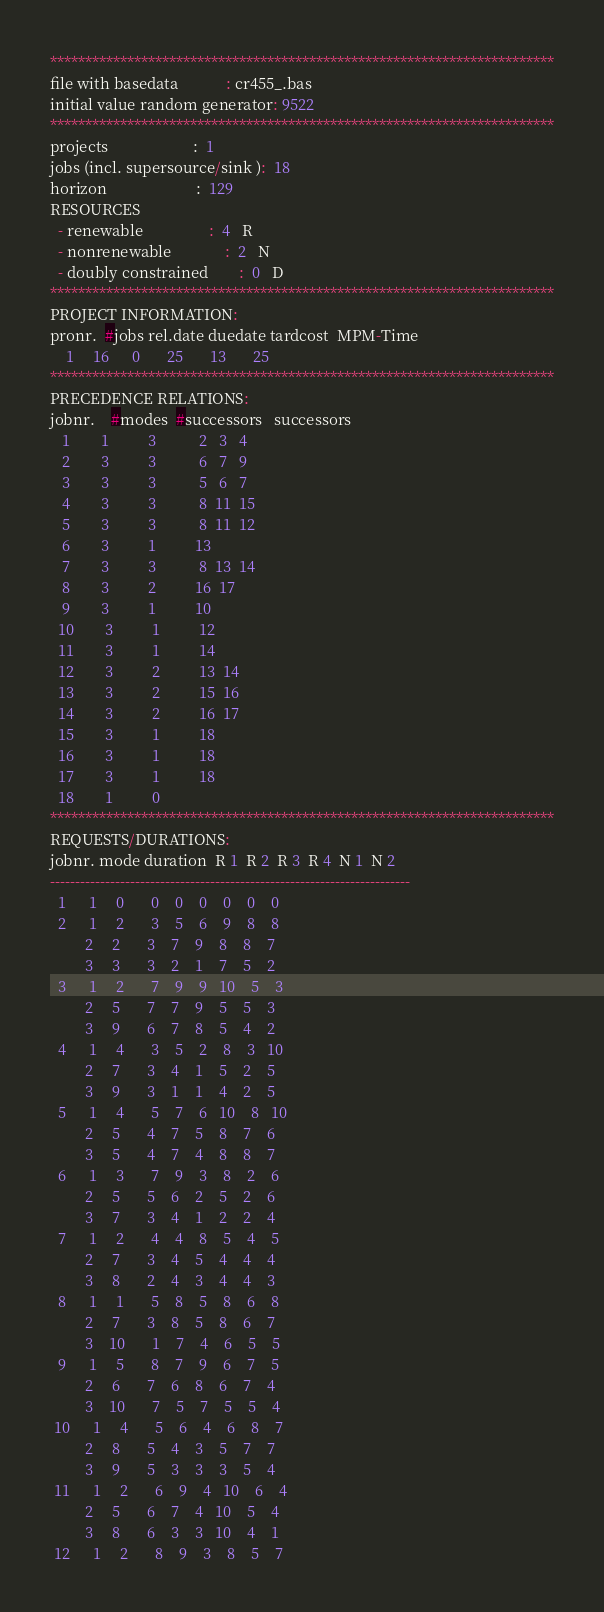<code> <loc_0><loc_0><loc_500><loc_500><_ObjectiveC_>************************************************************************
file with basedata            : cr455_.bas
initial value random generator: 9522
************************************************************************
projects                      :  1
jobs (incl. supersource/sink ):  18
horizon                       :  129
RESOURCES
  - renewable                 :  4   R
  - nonrenewable              :  2   N
  - doubly constrained        :  0   D
************************************************************************
PROJECT INFORMATION:
pronr.  #jobs rel.date duedate tardcost  MPM-Time
    1     16      0       25       13       25
************************************************************************
PRECEDENCE RELATIONS:
jobnr.    #modes  #successors   successors
   1        1          3           2   3   4
   2        3          3           6   7   9
   3        3          3           5   6   7
   4        3          3           8  11  15
   5        3          3           8  11  12
   6        3          1          13
   7        3          3           8  13  14
   8        3          2          16  17
   9        3          1          10
  10        3          1          12
  11        3          1          14
  12        3          2          13  14
  13        3          2          15  16
  14        3          2          16  17
  15        3          1          18
  16        3          1          18
  17        3          1          18
  18        1          0        
************************************************************************
REQUESTS/DURATIONS:
jobnr. mode duration  R 1  R 2  R 3  R 4  N 1  N 2
------------------------------------------------------------------------
  1      1     0       0    0    0    0    0    0
  2      1     2       3    5    6    9    8    8
         2     2       3    7    9    8    8    7
         3     3       3    2    1    7    5    2
  3      1     2       7    9    9   10    5    3
         2     5       7    7    9    5    5    3
         3     9       6    7    8    5    4    2
  4      1     4       3    5    2    8    3   10
         2     7       3    4    1    5    2    5
         3     9       3    1    1    4    2    5
  5      1     4       5    7    6   10    8   10
         2     5       4    7    5    8    7    6
         3     5       4    7    4    8    8    7
  6      1     3       7    9    3    8    2    6
         2     5       5    6    2    5    2    6
         3     7       3    4    1    2    2    4
  7      1     2       4    4    8    5    4    5
         2     7       3    4    5    4    4    4
         3     8       2    4    3    4    4    3
  8      1     1       5    8    5    8    6    8
         2     7       3    8    5    8    6    7
         3    10       1    7    4    6    5    5
  9      1     5       8    7    9    6    7    5
         2     6       7    6    8    6    7    4
         3    10       7    5    7    5    5    4
 10      1     4       5    6    4    6    8    7
         2     8       5    4    3    5    7    7
         3     9       5    3    3    3    5    4
 11      1     2       6    9    4   10    6    4
         2     5       6    7    4   10    5    4
         3     8       6    3    3   10    4    1
 12      1     2       8    9    3    8    5    7</code> 